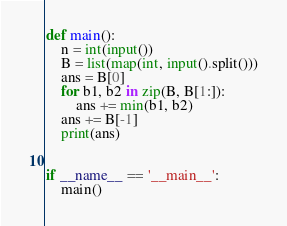<code> <loc_0><loc_0><loc_500><loc_500><_Python_>def main():
    n = int(input())
    B = list(map(int, input().split()))
    ans = B[0]
    for b1, b2 in zip(B, B[1:]):
        ans += min(b1, b2)
    ans += B[-1]
    print(ans)


if __name__ == '__main__':
    main()
</code> 